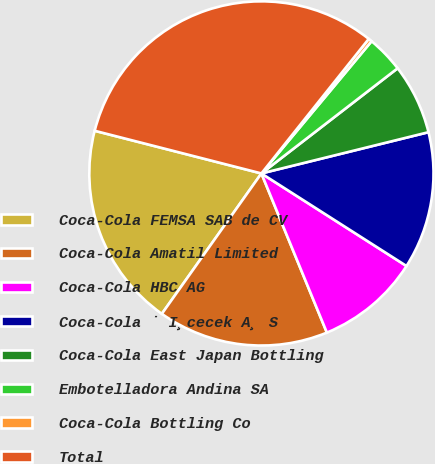<chart> <loc_0><loc_0><loc_500><loc_500><pie_chart><fcel>Coca-Cola FEMSA SAB de CV<fcel>Coca-Cola Amatil Limited<fcel>Coca-Cola HBC AG<fcel>Coca-Cola ˙ I¸cecek A¸ S<fcel>Coca-Cola East Japan Bottling<fcel>Embotelladora Andina SA<fcel>Coca-Cola Bottling Co<fcel>Total<nl><fcel>19.17%<fcel>16.03%<fcel>9.75%<fcel>12.89%<fcel>6.61%<fcel>3.48%<fcel>0.34%<fcel>31.73%<nl></chart> 